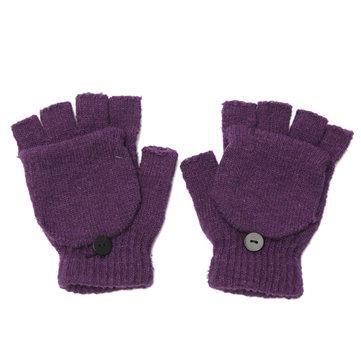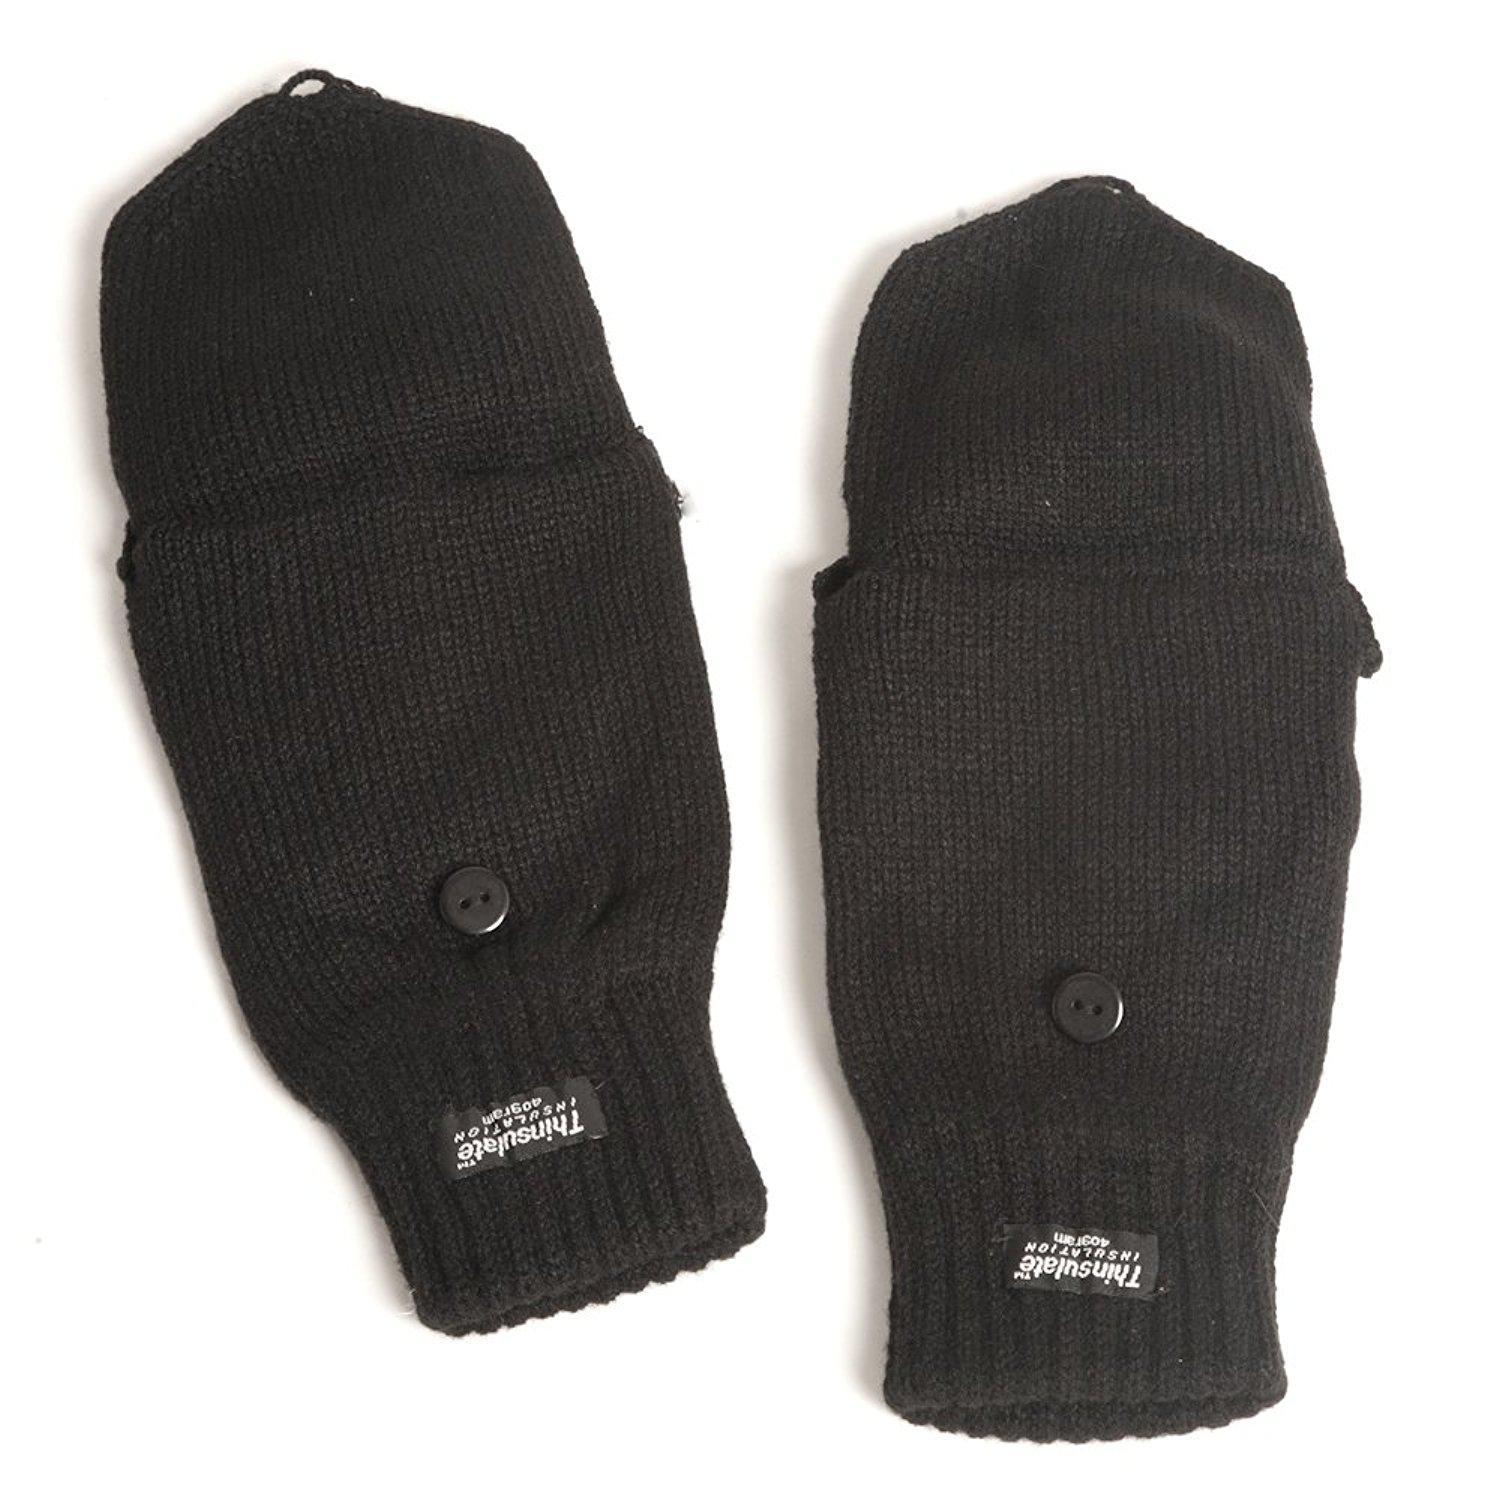The first image is the image on the left, the second image is the image on the right. Considering the images on both sides, is "Two mittens are shown covered." valid? Answer yes or no. Yes. 